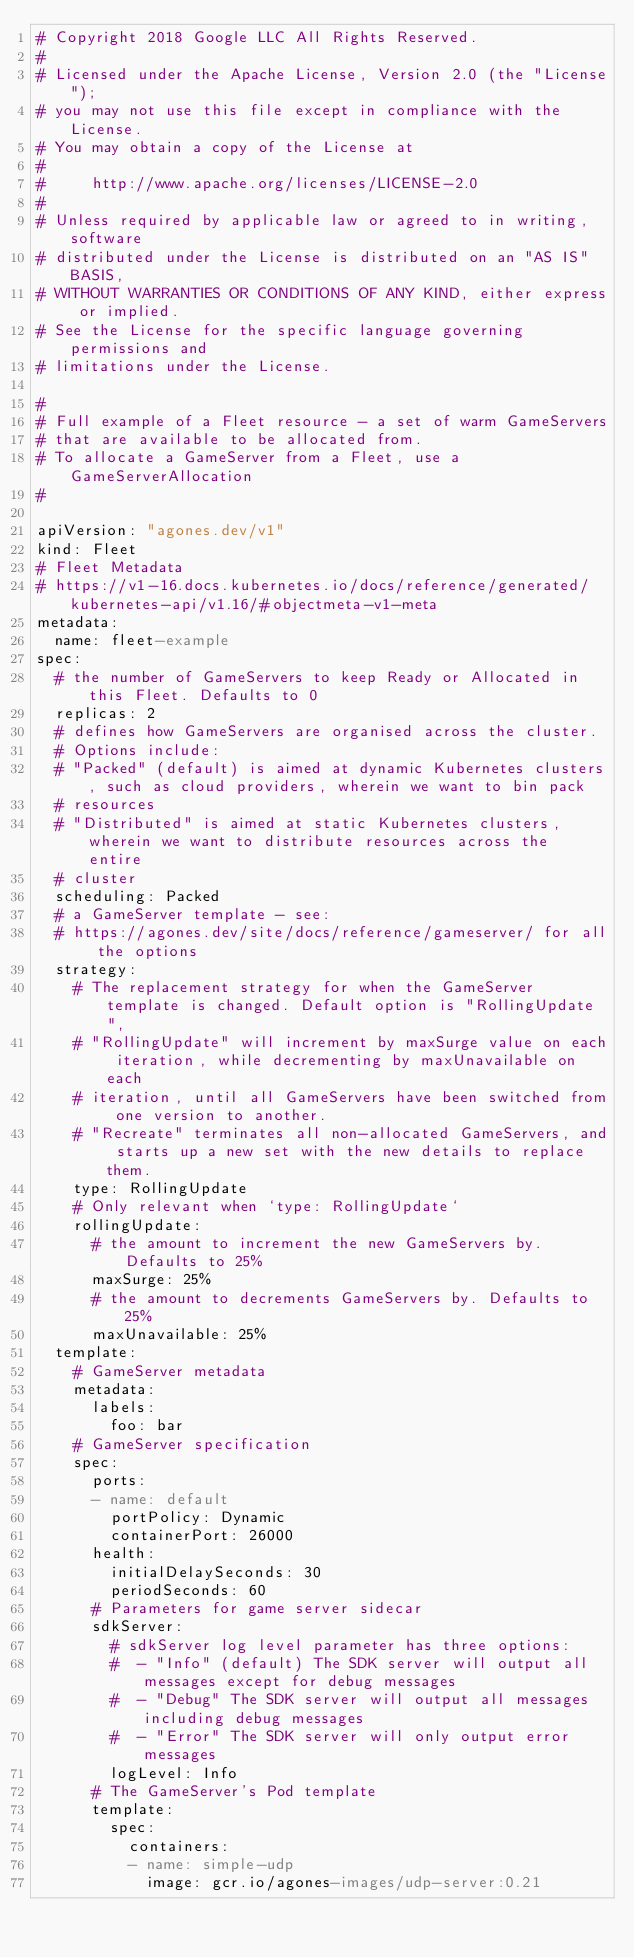Convert code to text. <code><loc_0><loc_0><loc_500><loc_500><_YAML_># Copyright 2018 Google LLC All Rights Reserved.
#
# Licensed under the Apache License, Version 2.0 (the "License");
# you may not use this file except in compliance with the License.
# You may obtain a copy of the License at
#
#     http://www.apache.org/licenses/LICENSE-2.0
#
# Unless required by applicable law or agreed to in writing, software
# distributed under the License is distributed on an "AS IS" BASIS,
# WITHOUT WARRANTIES OR CONDITIONS OF ANY KIND, either express or implied.
# See the License for the specific language governing permissions and
# limitations under the License.

#
# Full example of a Fleet resource - a set of warm GameServers
# that are available to be allocated from.
# To allocate a GameServer from a Fleet, use a GameServerAllocation
#

apiVersion: "agones.dev/v1"
kind: Fleet
# Fleet Metadata
# https://v1-16.docs.kubernetes.io/docs/reference/generated/kubernetes-api/v1.16/#objectmeta-v1-meta
metadata:
  name: fleet-example
spec:
  # the number of GameServers to keep Ready or Allocated in this Fleet. Defaults to 0
  replicas: 2
  # defines how GameServers are organised across the cluster.
  # Options include:
  # "Packed" (default) is aimed at dynamic Kubernetes clusters, such as cloud providers, wherein we want to bin pack
  # resources
  # "Distributed" is aimed at static Kubernetes clusters, wherein we want to distribute resources across the entire
  # cluster
  scheduling: Packed
  # a GameServer template - see:
  # https://agones.dev/site/docs/reference/gameserver/ for all the options
  strategy:
    # The replacement strategy for when the GameServer template is changed. Default option is "RollingUpdate",
    # "RollingUpdate" will increment by maxSurge value on each iteration, while decrementing by maxUnavailable on each
    # iteration, until all GameServers have been switched from one version to another.
    # "Recreate" terminates all non-allocated GameServers, and starts up a new set with the new details to replace them.
    type: RollingUpdate
    # Only relevant when `type: RollingUpdate`
    rollingUpdate:
      # the amount to increment the new GameServers by. Defaults to 25%
      maxSurge: 25%
      # the amount to decrements GameServers by. Defaults to 25%
      maxUnavailable: 25%
  template:
    # GameServer metadata
    metadata:
      labels:
        foo: bar
    # GameServer specification
    spec:
      ports:
      - name: default
        portPolicy: Dynamic
        containerPort: 26000
      health:
        initialDelaySeconds: 30
        periodSeconds: 60
      # Parameters for game server sidecar
      sdkServer:
        # sdkServer log level parameter has three options:
        #  - "Info" (default) The SDK server will output all messages except for debug messages
        #  - "Debug" The SDK server will output all messages including debug messages
        #  - "Error" The SDK server will only output error messages
        logLevel: Info
      # The GameServer's Pod template
      template:
        spec:
          containers:
          - name: simple-udp
            image: gcr.io/agones-images/udp-server:0.21</code> 